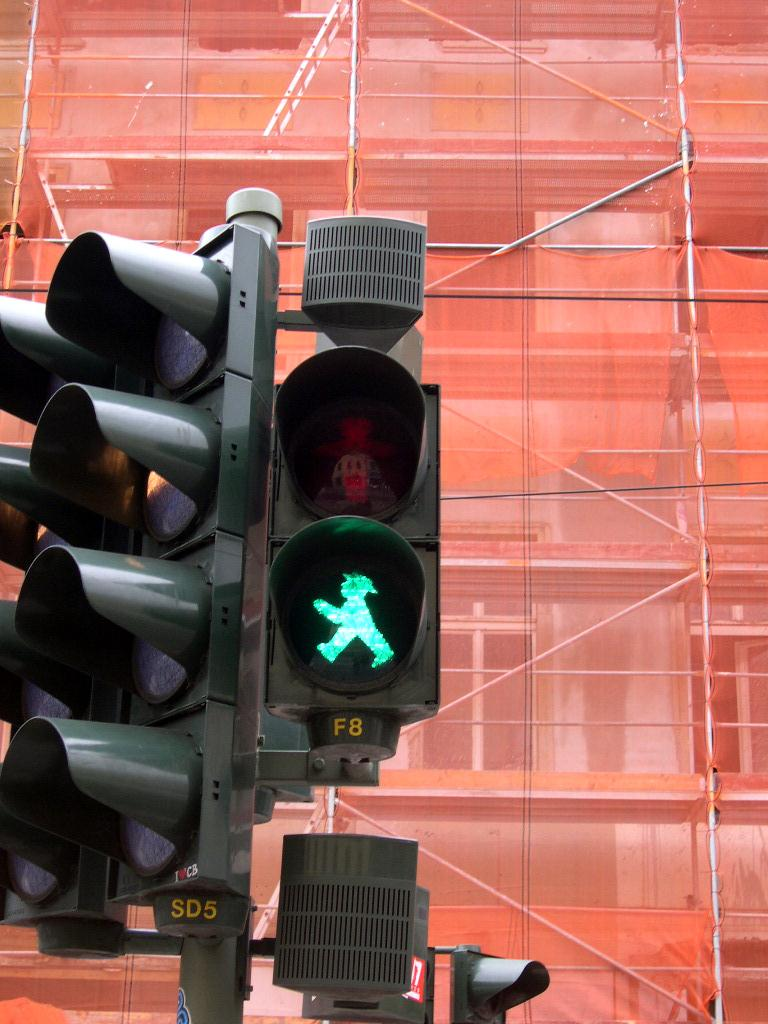<image>
Summarize the visual content of the image. The text F8 can be seen under the green figure. 